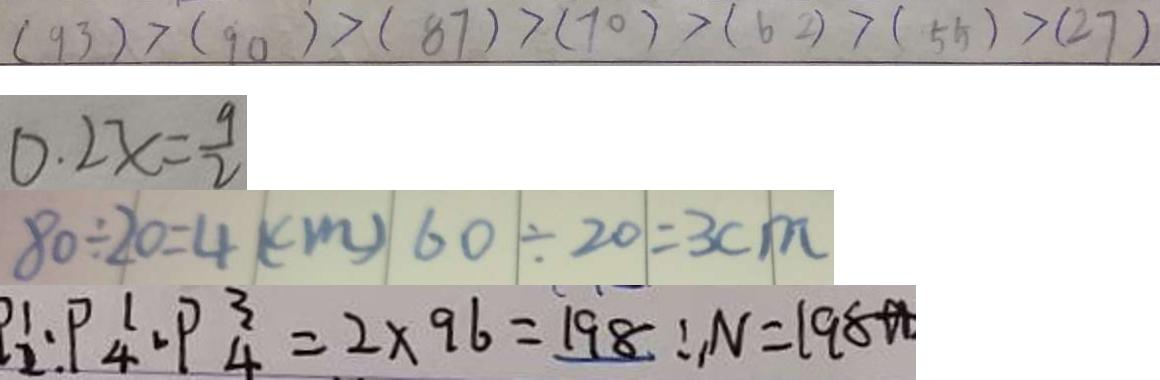Convert formula to latex. <formula><loc_0><loc_0><loc_500><loc_500>( 9 3 ) > ( 9 0 ) > ( 8 7 ) > ( 7 0 ) > ( 6 2 ) > ( 5 5 ) > ( 2 7 ) 
 0 . 2 x = \frac { 9 } { 2 } 
 8 0 \div 2 0 = 4 ( c m ) 6 0 \div 2 0 = 3 c m 
 P _ { 2 } ^ { 1 } \cdot P _ { 4 } ^ { 1 } \cdot P _ { 4 } ^ { 3 } = 2 \times 9 6 = 1 9 8 \therefore N = 1 9 8</formula> 